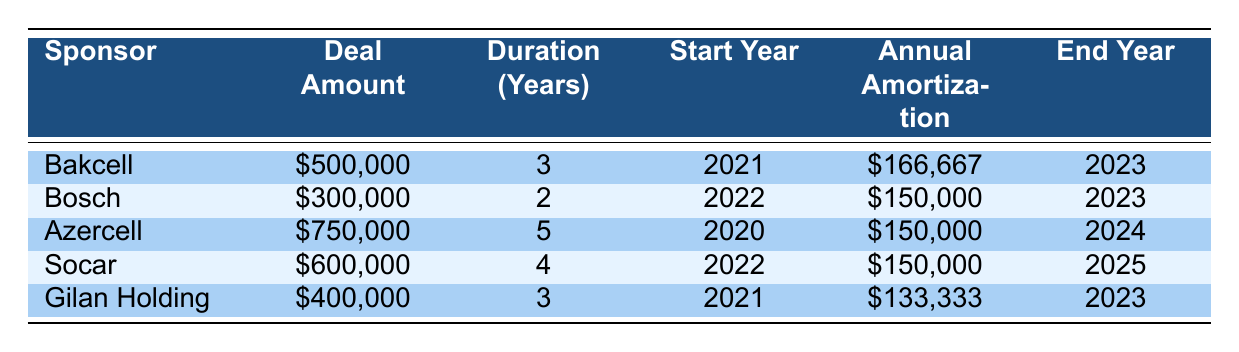What is the total deal amount from all sponsorships listed in the table? The total deal amount can be calculated by summing the deal amounts of all sponsors: 500000 + 300000 + 750000 + 600000 + 400000 = 2550000.
Answer: 2550000 Which sponsor has the longest contract duration, and what is that duration? The sponsor with the longest contract duration is Azercell with a duration of 5 years, from 2020 to 2024.
Answer: Azercell, 5 years What sponsor started their deal in 2022? The sponsors that started their deals in 2022 are Bosch and Socar.
Answer: Bosch and Socar How much is the annual amortization for the Gilan Holding sponsorship deal? According to the table, the annual amortization for Gilan Holding is 133333.
Answer: 133333 Is the total annual amortization for all sponsorships in 2022 greater than 400000? To find out, we sum the annual amortization values for the sponsors whose deals started in 2022: Bosch (150000) + Socar (150000) = 300000, which is less than 400000.
Answer: No What is the difference in total annual amortization between the deals starting in 2020 and those starting in 2022? Total annual amortization for deals starting in 2020: Azercell (150000), total is 150000. For deals starting in 2022: Bosch (150000) + Socar (150000) = 300000. The difference is 300000 - 150000 = 150000.
Answer: 150000 Which sponsor has the smallest deal amount, and what is that amount? The sponsor with the smallest deal amount is Bosch with a deal amount of 300000.
Answer: Bosch, 300000 Is it true that all deals listed in the table will end by 2025? The deal with Azercell ends in 2024, and Socar ends in 2025; others all end by 2023. So, it is not true that all deals end by 2025.
Answer: No What is the average annual amortization across all sponsorship deals? The average annual amortization is calculated by summing the annual amortization values: 166667 + 150000 + 150000 + 150000 + 133333 = 800000, then dividing by the number of deals (5): 800000 / 5 = 160000.
Answer: 160000 